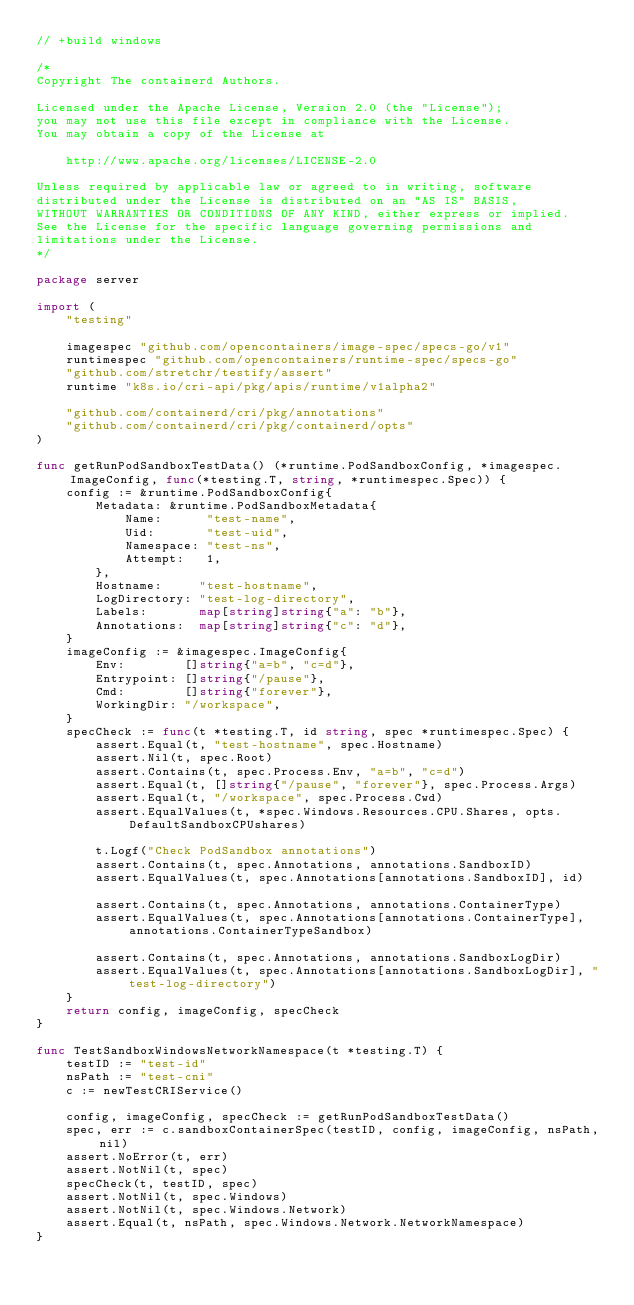Convert code to text. <code><loc_0><loc_0><loc_500><loc_500><_Go_>// +build windows

/*
Copyright The containerd Authors.

Licensed under the Apache License, Version 2.0 (the "License");
you may not use this file except in compliance with the License.
You may obtain a copy of the License at

    http://www.apache.org/licenses/LICENSE-2.0

Unless required by applicable law or agreed to in writing, software
distributed under the License is distributed on an "AS IS" BASIS,
WITHOUT WARRANTIES OR CONDITIONS OF ANY KIND, either express or implied.
See the License for the specific language governing permissions and
limitations under the License.
*/

package server

import (
	"testing"

	imagespec "github.com/opencontainers/image-spec/specs-go/v1"
	runtimespec "github.com/opencontainers/runtime-spec/specs-go"
	"github.com/stretchr/testify/assert"
	runtime "k8s.io/cri-api/pkg/apis/runtime/v1alpha2"

	"github.com/containerd/cri/pkg/annotations"
	"github.com/containerd/cri/pkg/containerd/opts"
)

func getRunPodSandboxTestData() (*runtime.PodSandboxConfig, *imagespec.ImageConfig, func(*testing.T, string, *runtimespec.Spec)) {
	config := &runtime.PodSandboxConfig{
		Metadata: &runtime.PodSandboxMetadata{
			Name:      "test-name",
			Uid:       "test-uid",
			Namespace: "test-ns",
			Attempt:   1,
		},
		Hostname:     "test-hostname",
		LogDirectory: "test-log-directory",
		Labels:       map[string]string{"a": "b"},
		Annotations:  map[string]string{"c": "d"},
	}
	imageConfig := &imagespec.ImageConfig{
		Env:        []string{"a=b", "c=d"},
		Entrypoint: []string{"/pause"},
		Cmd:        []string{"forever"},
		WorkingDir: "/workspace",
	}
	specCheck := func(t *testing.T, id string, spec *runtimespec.Spec) {
		assert.Equal(t, "test-hostname", spec.Hostname)
		assert.Nil(t, spec.Root)
		assert.Contains(t, spec.Process.Env, "a=b", "c=d")
		assert.Equal(t, []string{"/pause", "forever"}, spec.Process.Args)
		assert.Equal(t, "/workspace", spec.Process.Cwd)
		assert.EqualValues(t, *spec.Windows.Resources.CPU.Shares, opts.DefaultSandboxCPUshares)

		t.Logf("Check PodSandbox annotations")
		assert.Contains(t, spec.Annotations, annotations.SandboxID)
		assert.EqualValues(t, spec.Annotations[annotations.SandboxID], id)

		assert.Contains(t, spec.Annotations, annotations.ContainerType)
		assert.EqualValues(t, spec.Annotations[annotations.ContainerType], annotations.ContainerTypeSandbox)

		assert.Contains(t, spec.Annotations, annotations.SandboxLogDir)
		assert.EqualValues(t, spec.Annotations[annotations.SandboxLogDir], "test-log-directory")
	}
	return config, imageConfig, specCheck
}

func TestSandboxWindowsNetworkNamespace(t *testing.T) {
	testID := "test-id"
	nsPath := "test-cni"
	c := newTestCRIService()

	config, imageConfig, specCheck := getRunPodSandboxTestData()
	spec, err := c.sandboxContainerSpec(testID, config, imageConfig, nsPath, nil)
	assert.NoError(t, err)
	assert.NotNil(t, spec)
	specCheck(t, testID, spec)
	assert.NotNil(t, spec.Windows)
	assert.NotNil(t, spec.Windows.Network)
	assert.Equal(t, nsPath, spec.Windows.Network.NetworkNamespace)
}
</code> 